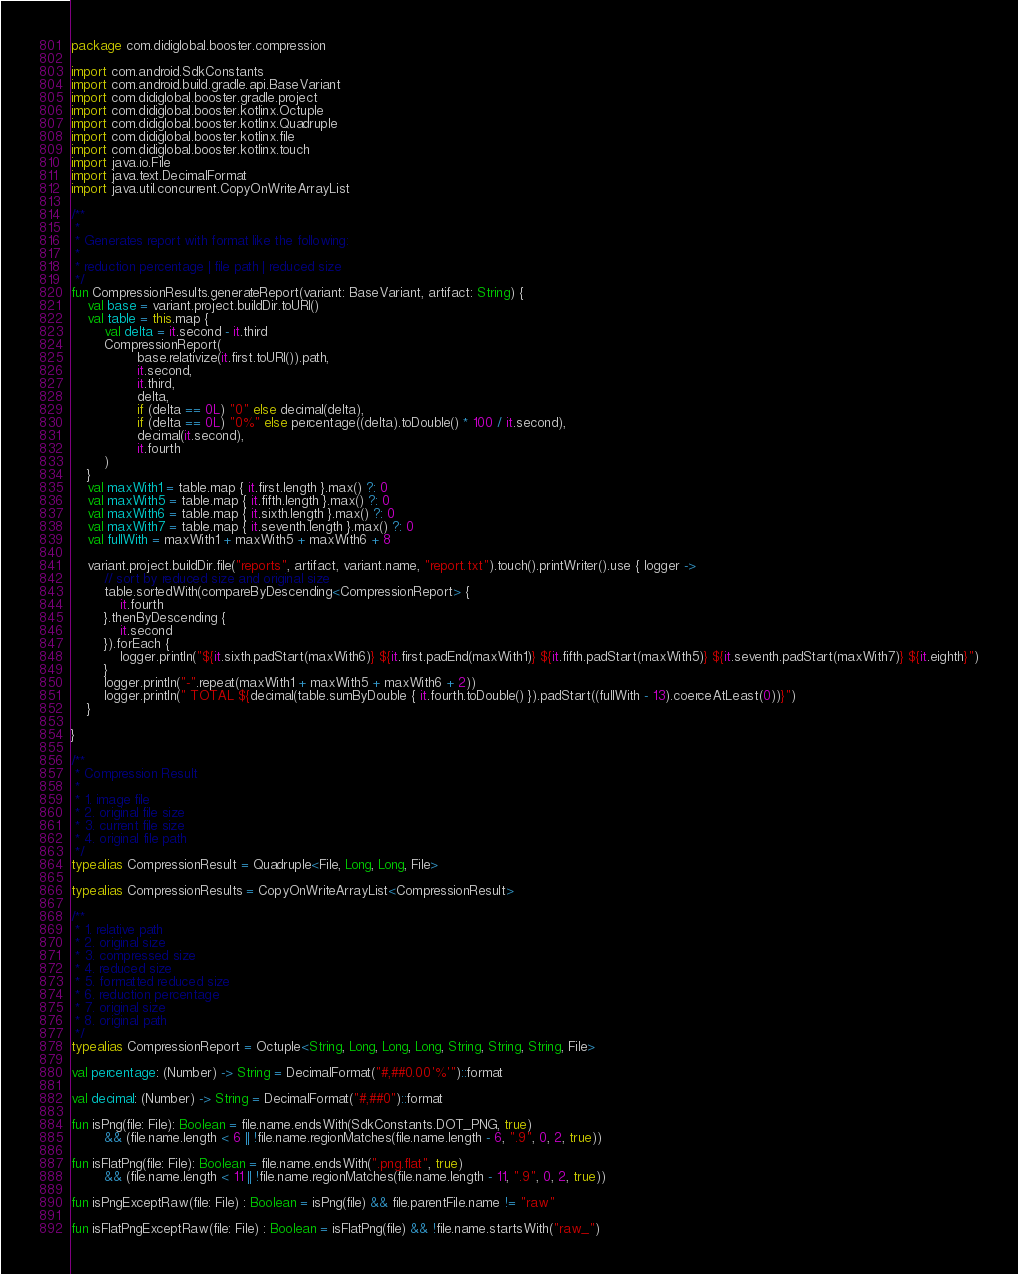Convert code to text. <code><loc_0><loc_0><loc_500><loc_500><_Kotlin_>package com.didiglobal.booster.compression

import com.android.SdkConstants
import com.android.build.gradle.api.BaseVariant
import com.didiglobal.booster.gradle.project
import com.didiglobal.booster.kotlinx.Octuple
import com.didiglobal.booster.kotlinx.Quadruple
import com.didiglobal.booster.kotlinx.file
import com.didiglobal.booster.kotlinx.touch
import java.io.File
import java.text.DecimalFormat
import java.util.concurrent.CopyOnWriteArrayList

/**
 *
 * Generates report with format like the following:
 *
 * reduction percentage | file path | reduced size
 */
fun CompressionResults.generateReport(variant: BaseVariant, artifact: String) {
    val base = variant.project.buildDir.toURI()
    val table = this.map {
        val delta = it.second - it.third
        CompressionReport(
                base.relativize(it.first.toURI()).path,
                it.second,
                it.third,
                delta,
                if (delta == 0L) "0" else decimal(delta),
                if (delta == 0L) "0%" else percentage((delta).toDouble() * 100 / it.second),
                decimal(it.second),
                it.fourth
        )
    }
    val maxWith1 = table.map { it.first.length }.max() ?: 0
    val maxWith5 = table.map { it.fifth.length }.max() ?: 0
    val maxWith6 = table.map { it.sixth.length }.max() ?: 0
    val maxWith7 = table.map { it.seventh.length }.max() ?: 0
    val fullWith = maxWith1 + maxWith5 + maxWith6 + 8

    variant.project.buildDir.file("reports", artifact, variant.name, "report.txt").touch().printWriter().use { logger ->
        // sort by reduced size and original size
        table.sortedWith(compareByDescending<CompressionReport> {
            it.fourth
        }.thenByDescending {
            it.second
        }).forEach {
            logger.println("${it.sixth.padStart(maxWith6)} ${it.first.padEnd(maxWith1)} ${it.fifth.padStart(maxWith5)} ${it.seventh.padStart(maxWith7)} ${it.eighth}")
        }
        logger.println("-".repeat(maxWith1 + maxWith5 + maxWith6 + 2))
        logger.println(" TOTAL ${decimal(table.sumByDouble { it.fourth.toDouble() }).padStart((fullWith - 13).coerceAtLeast(0))}")
    }

}

/**
 * Compression Result
 *
 * 1. image file
 * 2. original file size
 * 3. current file size
 * 4. original file path
 */
typealias CompressionResult = Quadruple<File, Long, Long, File>

typealias CompressionResults = CopyOnWriteArrayList<CompressionResult>

/**
 * 1. relative path
 * 2. original size
 * 3. compressed size
 * 4. reduced size
 * 5. formatted reduced size
 * 6. reduction percentage
 * 7. original size
 * 8. original path
 */
typealias CompressionReport = Octuple<String, Long, Long, Long, String, String, String, File>

val percentage: (Number) -> String = DecimalFormat("#,##0.00'%'")::format

val decimal: (Number) -> String = DecimalFormat("#,##0")::format

fun isPng(file: File): Boolean = file.name.endsWith(SdkConstants.DOT_PNG, true)
        && (file.name.length < 6 || !file.name.regionMatches(file.name.length - 6, ".9", 0, 2, true))

fun isFlatPng(file: File): Boolean = file.name.endsWith(".png.flat", true)
        && (file.name.length < 11 || !file.name.regionMatches(file.name.length - 11, ".9", 0, 2, true))

fun isPngExceptRaw(file: File) : Boolean = isPng(file) && file.parentFile.name != "raw"

fun isFlatPngExceptRaw(file: File) : Boolean = isFlatPng(file) && !file.name.startsWith("raw_")
</code> 